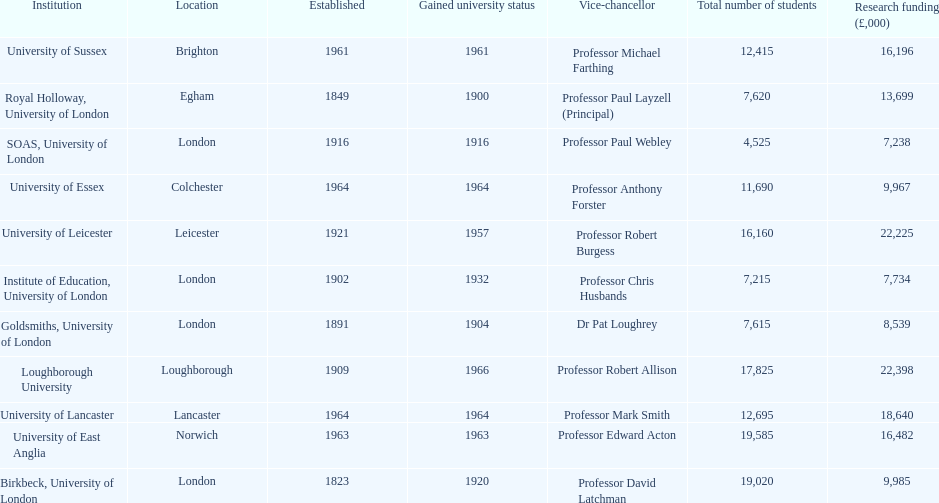What is the most recent institution to gain university status? Loughborough University. 